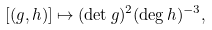Convert formula to latex. <formula><loc_0><loc_0><loc_500><loc_500>[ ( g , h ) ] \mapsto ( \det g ) ^ { 2 } ( \deg h ) ^ { - 3 } ,</formula> 